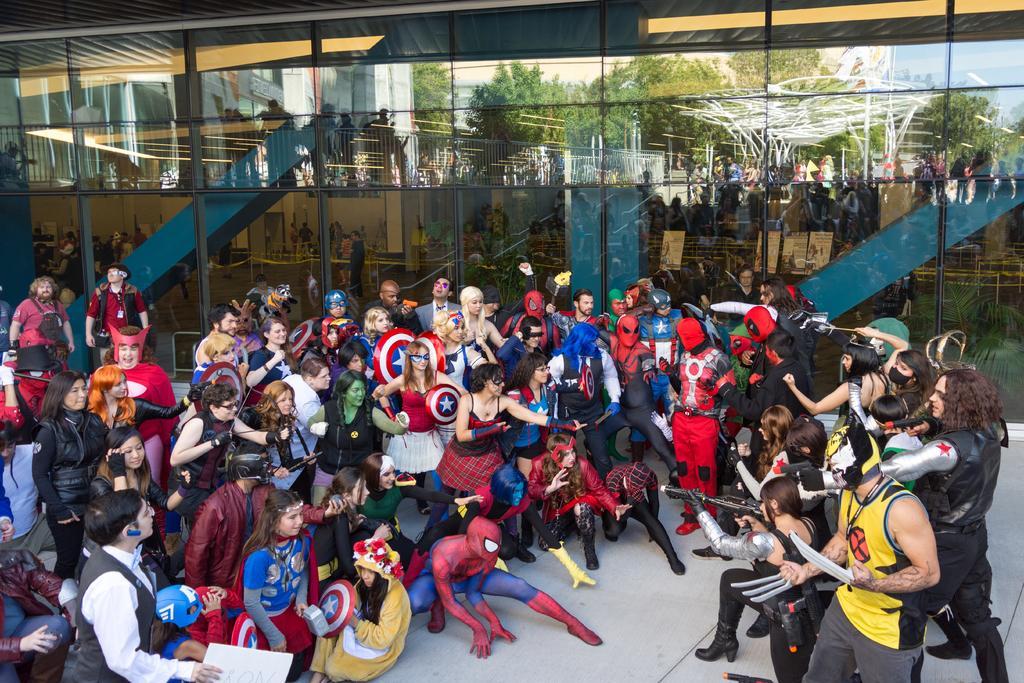Can you describe this image briefly? There are people wore different costumes and we can see glass, through this glass we can see people, building, trees and sky. 